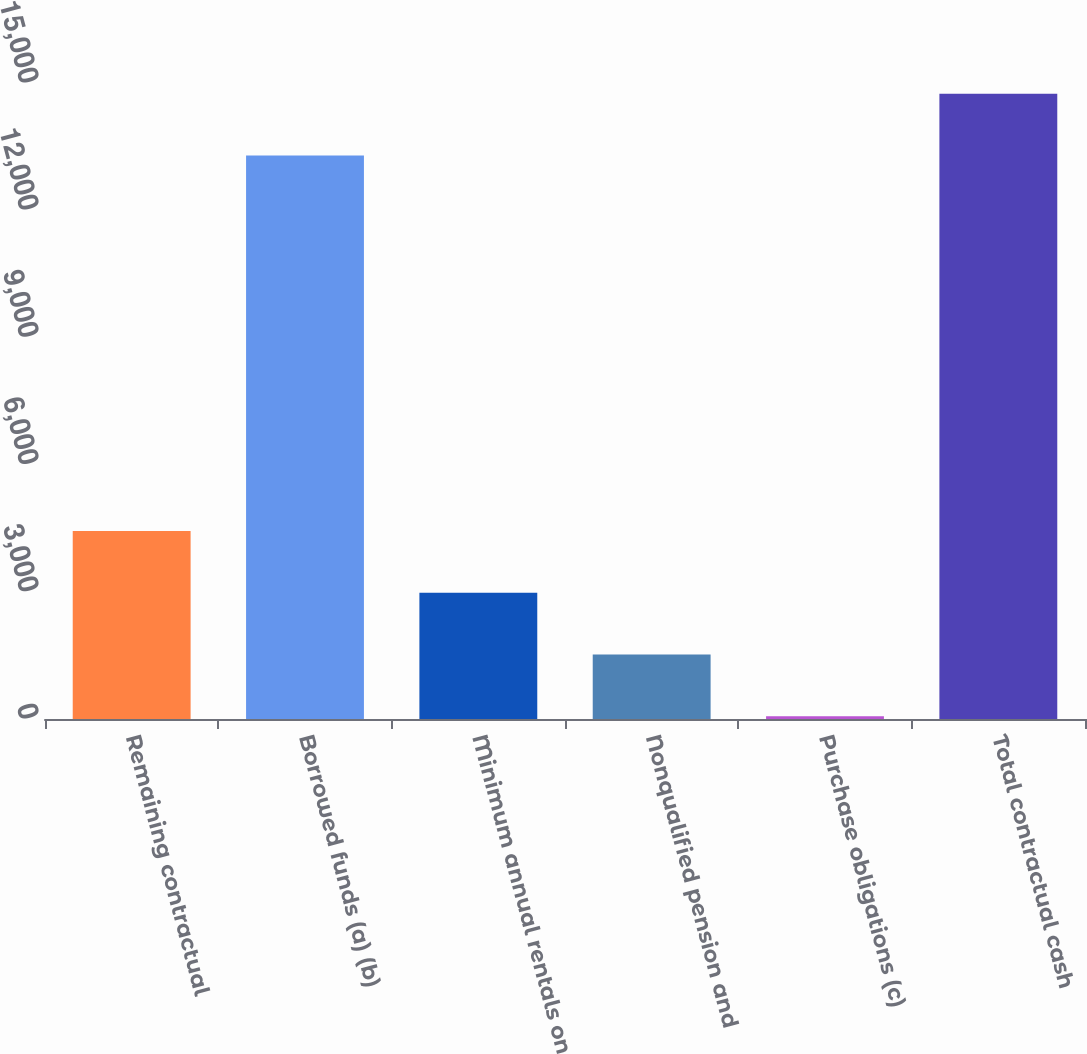<chart> <loc_0><loc_0><loc_500><loc_500><bar_chart><fcel>Remaining contractual<fcel>Borrowed funds (a) (b)<fcel>Minimum annual rentals on<fcel>Nonqualified pension and<fcel>Purchase obligations (c)<fcel>Total contractual cash<nl><fcel>4434.3<fcel>13291<fcel>2977.2<fcel>1520.1<fcel>63<fcel>14748.1<nl></chart> 